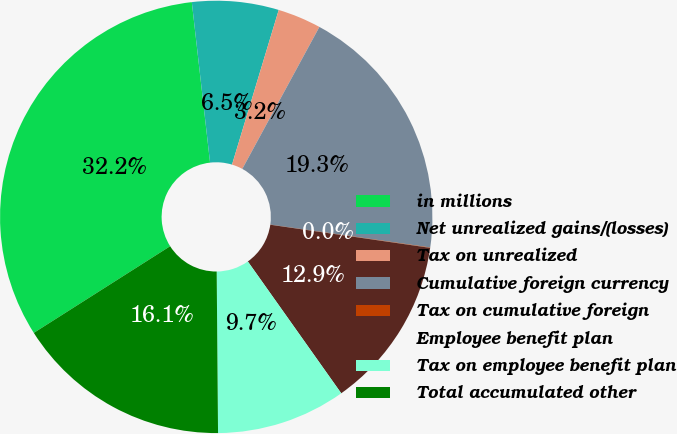Convert chart. <chart><loc_0><loc_0><loc_500><loc_500><pie_chart><fcel>in millions<fcel>Net unrealized gains/(losses)<fcel>Tax on unrealized<fcel>Cumulative foreign currency<fcel>Tax on cumulative foreign<fcel>Employee benefit plan<fcel>Tax on employee benefit plan<fcel>Total accumulated other<nl><fcel>32.21%<fcel>6.47%<fcel>3.25%<fcel>19.34%<fcel>0.03%<fcel>12.9%<fcel>9.68%<fcel>16.12%<nl></chart> 